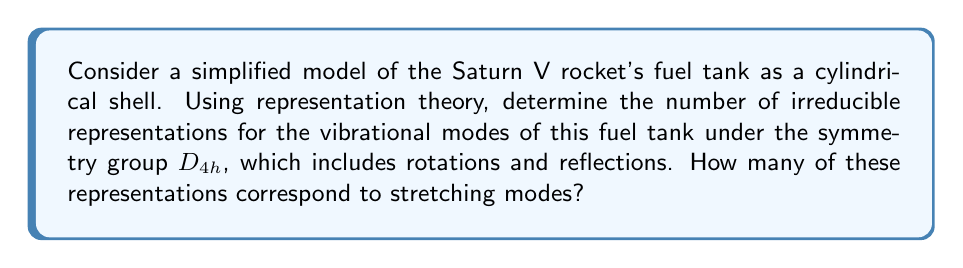Teach me how to tackle this problem. To solve this problem, we'll follow these steps:

1) The symmetry group $D_{4h}$ has 16 symmetry operations, divided into 10 classes:

   $E$, $2C_4$, $C_2$, $2C_2'$, $2C_2''$, $i$, $2S_4$, $\sigma_h$, $2\sigma_v$, $2\sigma_d$

2) The number of irreducible representations is equal to the number of classes. So, there are 10 irreducible representations.

3) These representations are:

   $A_{1g}$, $A_{2g}$, $B_{1g}$, $B_{2g}$, $E_g$, $A_{1u}$, $A_{2u}$, $B_{1u}$, $B_{2u}$, $E_u$

4) To determine which of these correspond to stretching modes, we need to consider the symmetry of the stretching vibrations.

5) Stretching modes typically transform as the totally symmetric representation ($A_{1g}$) and as representations that change sign under inversion ($u$ subscript).

6) In this case, the stretching modes correspond to:

   $A_{1g}$ (symmetric stretch)
   $A_{1u}$ (antisymmetric stretch)
   $E_u$ (doubly degenerate stretch)

7) Therefore, there are 3 representations corresponding to stretching modes.

This analysis provides a framework for understanding the vibrational modes of the fuel tank, which would have been crucial for engineers working on the Apollo program to ensure the structural integrity of the rocket during launch and flight.
Answer: 10 irreducible representations; 3 stretching modes 